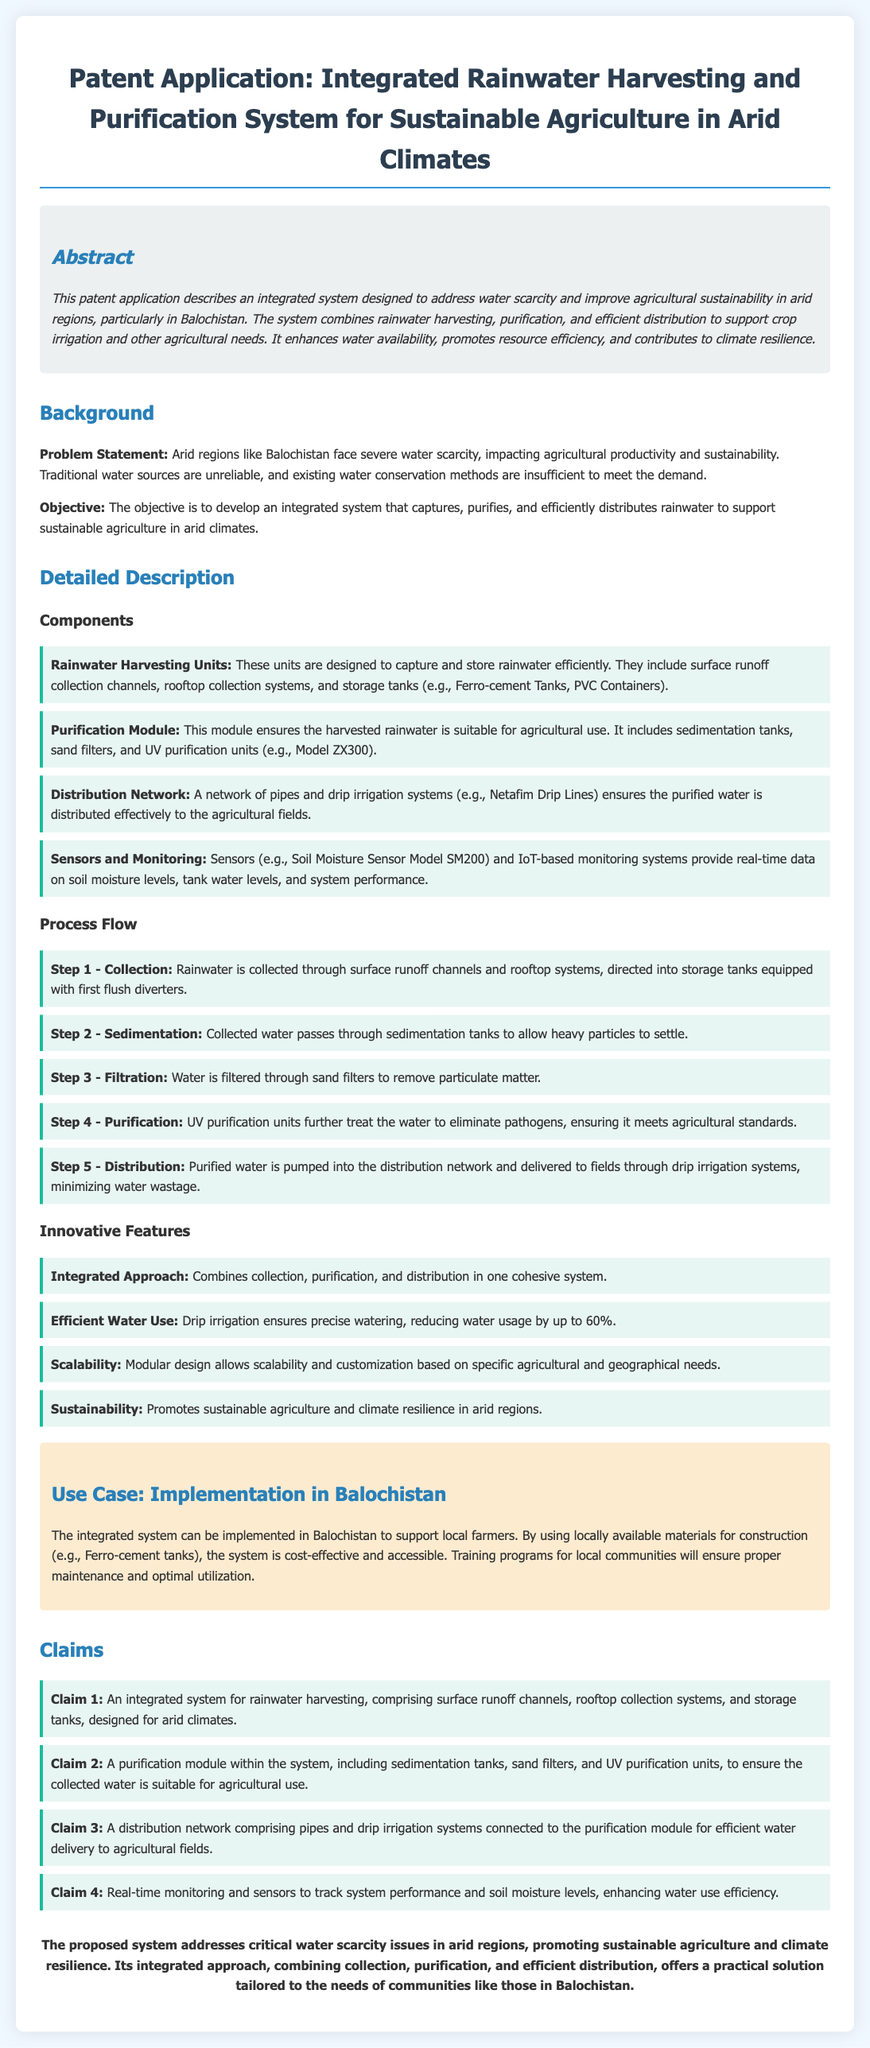what is the title of the patent application? The title provides a summary of the content of the document, including the focus on an integrated rainwater harvesting system for sustainable agriculture in arid climates.
Answer: Integrated Rainwater Harvesting and Purification System for Sustainable Agriculture in Arid Climates what is the main problem addressed by the system? The problem statement outlines the specific issue that the invention aims to solve, which is the water scarcity in arid regions.
Answer: Water scarcity what are the components of the purification module? This question requires identifying specific elements included in the purification module as listed in the document.
Answer: Sedimentation tanks, sand filters, UV purification units how much water usage can drip irrigation reduce by? This question inquires about a quantifiable feature of the system that demonstrates its efficiency in water usage.
Answer: Up to 60% what is the objective of the integrated system? The objective section clarifies the goal that the integrated system aims to achieve, focusing on sustainable agriculture.
Answer: Sustainable agriculture in arid climates who can benefit from the implementation of the system in Balochistan? This question identifies the target beneficiaries of the proposed system and its implementation.
Answer: Local farmers what type of monitoring does the system include? This question seeks to identify the technology used for real-time tracking and monitoring within the system.
Answer: Sensors and IoT-based monitoring systems how many claims are listed in the document? This requires a numerical answer regarding the structure of the patent application, specifically focusing on the claims portion.
Answer: Four claims 